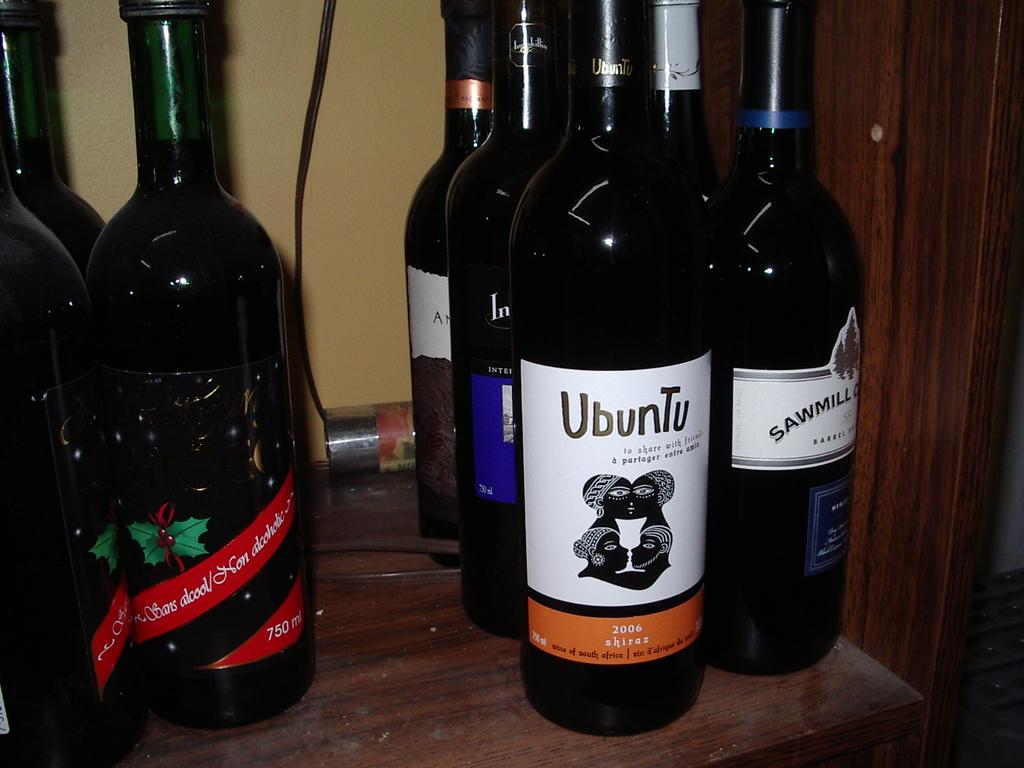<image>
Give a short and clear explanation of the subsequent image. amber bottles of ubunta wine to share with friends 